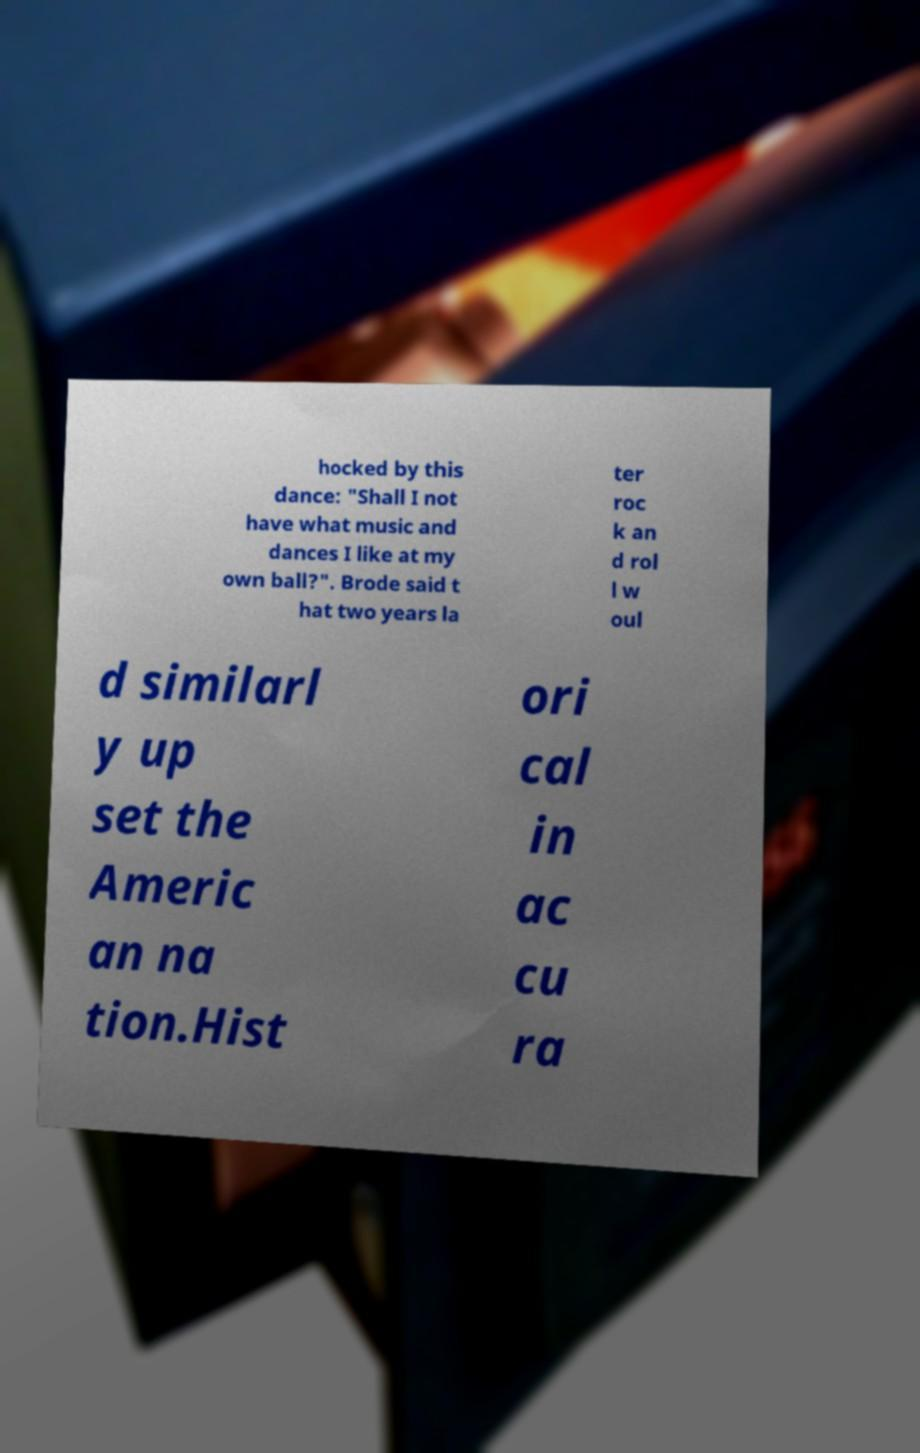Please identify and transcribe the text found in this image. hocked by this dance: "Shall I not have what music and dances I like at my own ball?". Brode said t hat two years la ter roc k an d rol l w oul d similarl y up set the Americ an na tion.Hist ori cal in ac cu ra 